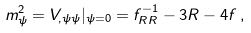<formula> <loc_0><loc_0><loc_500><loc_500>m _ { \psi } ^ { 2 } = V _ { , \psi \psi } | _ { \psi = 0 } = f _ { R R } ^ { - 1 } - 3 R - 4 f \, ,</formula> 